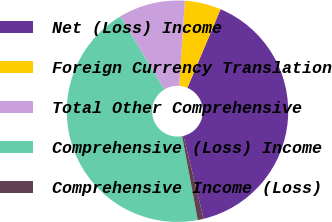<chart> <loc_0><loc_0><loc_500><loc_500><pie_chart><fcel>Net (Loss) Income<fcel>Foreign Currency Translation<fcel>Total Other Comprehensive<fcel>Comprehensive (Loss) Income<fcel>Comprehensive Income (Loss)<nl><fcel>39.85%<fcel>5.29%<fcel>9.72%<fcel>44.28%<fcel>0.86%<nl></chart> 